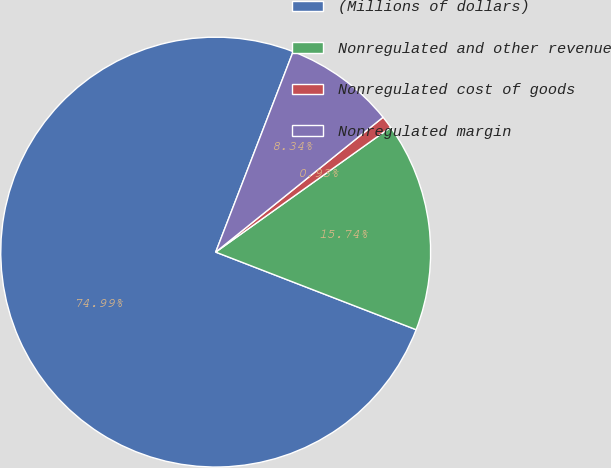<chart> <loc_0><loc_0><loc_500><loc_500><pie_chart><fcel>(Millions of dollars)<fcel>Nonregulated and other revenue<fcel>Nonregulated cost of goods<fcel>Nonregulated margin<nl><fcel>74.98%<fcel>15.74%<fcel>0.93%<fcel>8.34%<nl></chart> 